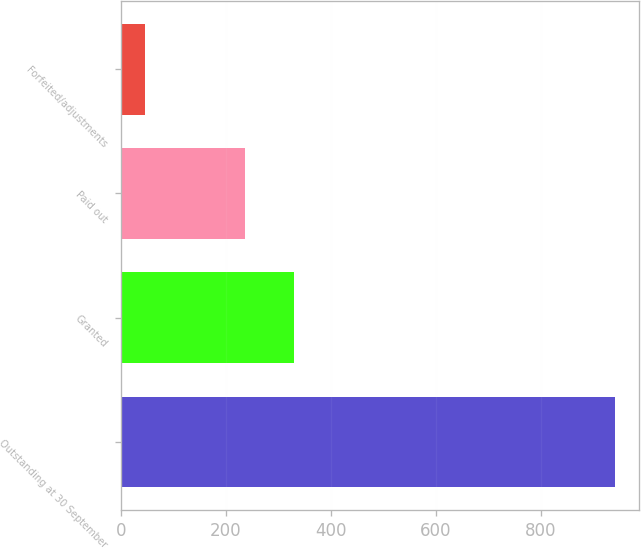Convert chart to OTSL. <chart><loc_0><loc_0><loc_500><loc_500><bar_chart><fcel>Outstanding at 30 September<fcel>Granted<fcel>Paid out<fcel>Forfeited/adjustments<nl><fcel>940<fcel>329.8<fcel>237<fcel>47<nl></chart> 